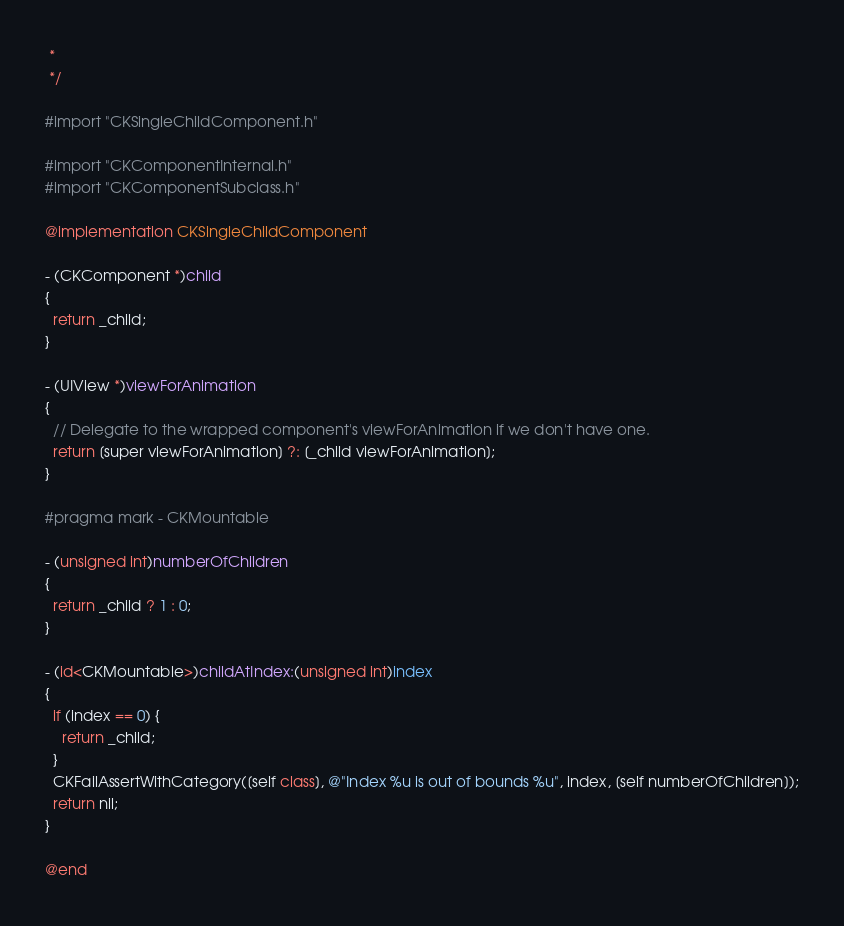<code> <loc_0><loc_0><loc_500><loc_500><_ObjectiveC_> *
 */

#import "CKSingleChildComponent.h"

#import "CKComponentInternal.h"
#import "CKComponentSubclass.h"

@implementation CKSingleChildComponent

- (CKComponent *)child
{
  return _child;
}

- (UIView *)viewForAnimation
{
  // Delegate to the wrapped component's viewForAnimation if we don't have one.
  return [super viewForAnimation] ?: [_child viewForAnimation];
}

#pragma mark - CKMountable

- (unsigned int)numberOfChildren
{
  return _child ? 1 : 0;
}

- (id<CKMountable>)childAtIndex:(unsigned int)index
{
  if (index == 0) {
    return _child;
  }
  CKFailAssertWithCategory([self class], @"Index %u is out of bounds %u", index, [self numberOfChildren]);
  return nil;
}

@end
</code> 